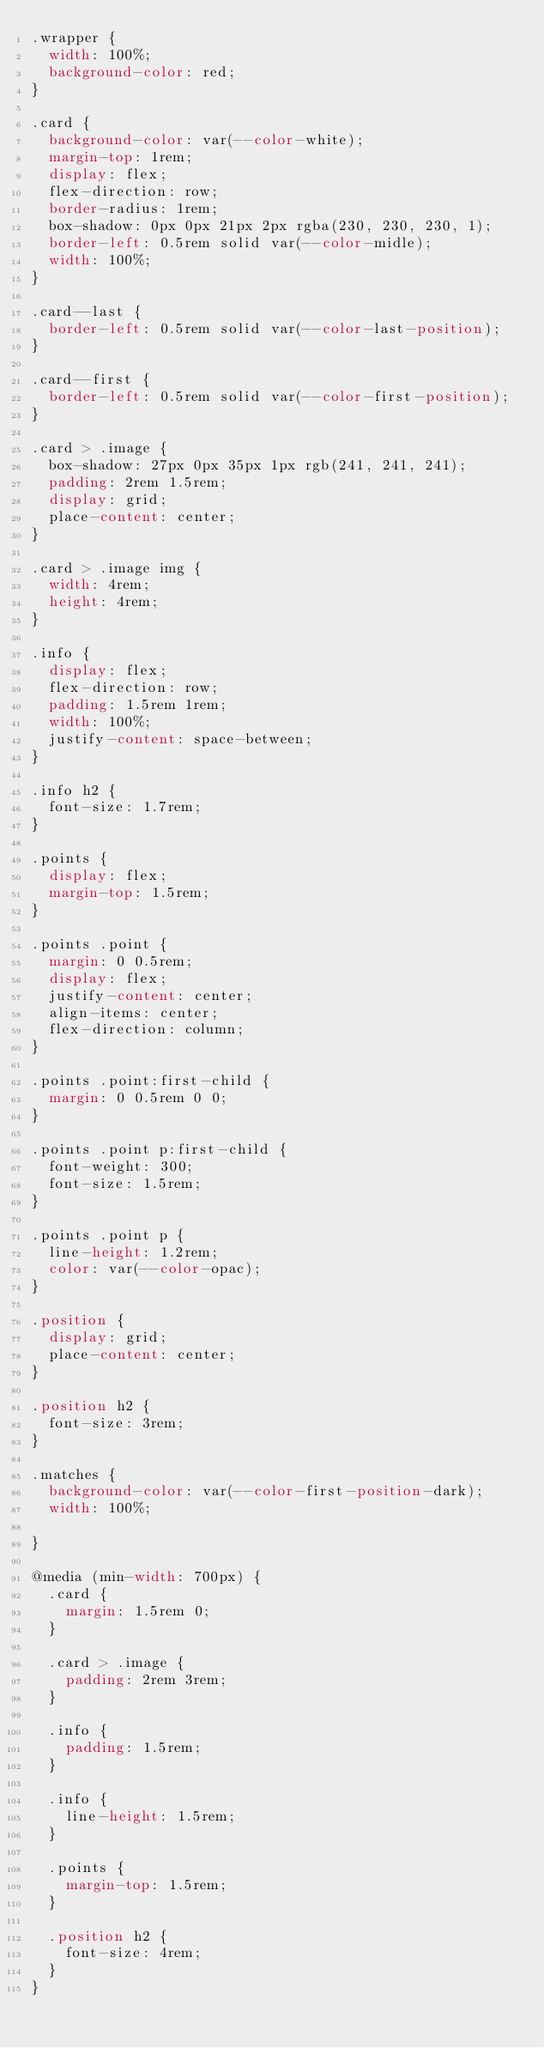<code> <loc_0><loc_0><loc_500><loc_500><_CSS_>.wrapper {
  width: 100%;
  background-color: red;
}

.card {
  background-color: var(--color-white);
  margin-top: 1rem;
  display: flex;
  flex-direction: row;
  border-radius: 1rem;
  box-shadow: 0px 0px 21px 2px rgba(230, 230, 230, 1);
  border-left: 0.5rem solid var(--color-midle);
  width: 100%;
}

.card--last {
  border-left: 0.5rem solid var(--color-last-position);
}

.card--first {
  border-left: 0.5rem solid var(--color-first-position);
}

.card > .image {
  box-shadow: 27px 0px 35px 1px rgb(241, 241, 241);
  padding: 2rem 1.5rem;
  display: grid;
  place-content: center;
}

.card > .image img {
  width: 4rem;
  height: 4rem;
}

.info {
  display: flex;
  flex-direction: row;
  padding: 1.5rem 1rem;
  width: 100%;
  justify-content: space-between;
}

.info h2 {
  font-size: 1.7rem;
}

.points {
  display: flex;
  margin-top: 1.5rem;
}

.points .point {
  margin: 0 0.5rem;
  display: flex;
  justify-content: center;
  align-items: center;
  flex-direction: column;
}

.points .point:first-child {
  margin: 0 0.5rem 0 0;
}

.points .point p:first-child {
  font-weight: 300;
  font-size: 1.5rem;
}

.points .point p {
  line-height: 1.2rem;
  color: var(--color-opac);
}

.position {
  display: grid;
  place-content: center;
}

.position h2 {
  font-size: 3rem;
}

.matches {
  background-color: var(--color-first-position-dark);
  width: 100%;

}

@media (min-width: 700px) {
  .card {
    margin: 1.5rem 0;
  }

  .card > .image {
    padding: 2rem 3rem;
  }

  .info {
    padding: 1.5rem;
  }

  .info {
    line-height: 1.5rem;
  }

  .points {
    margin-top: 1.5rem;
  }

  .position h2 {
    font-size: 4rem;
  }
}
</code> 